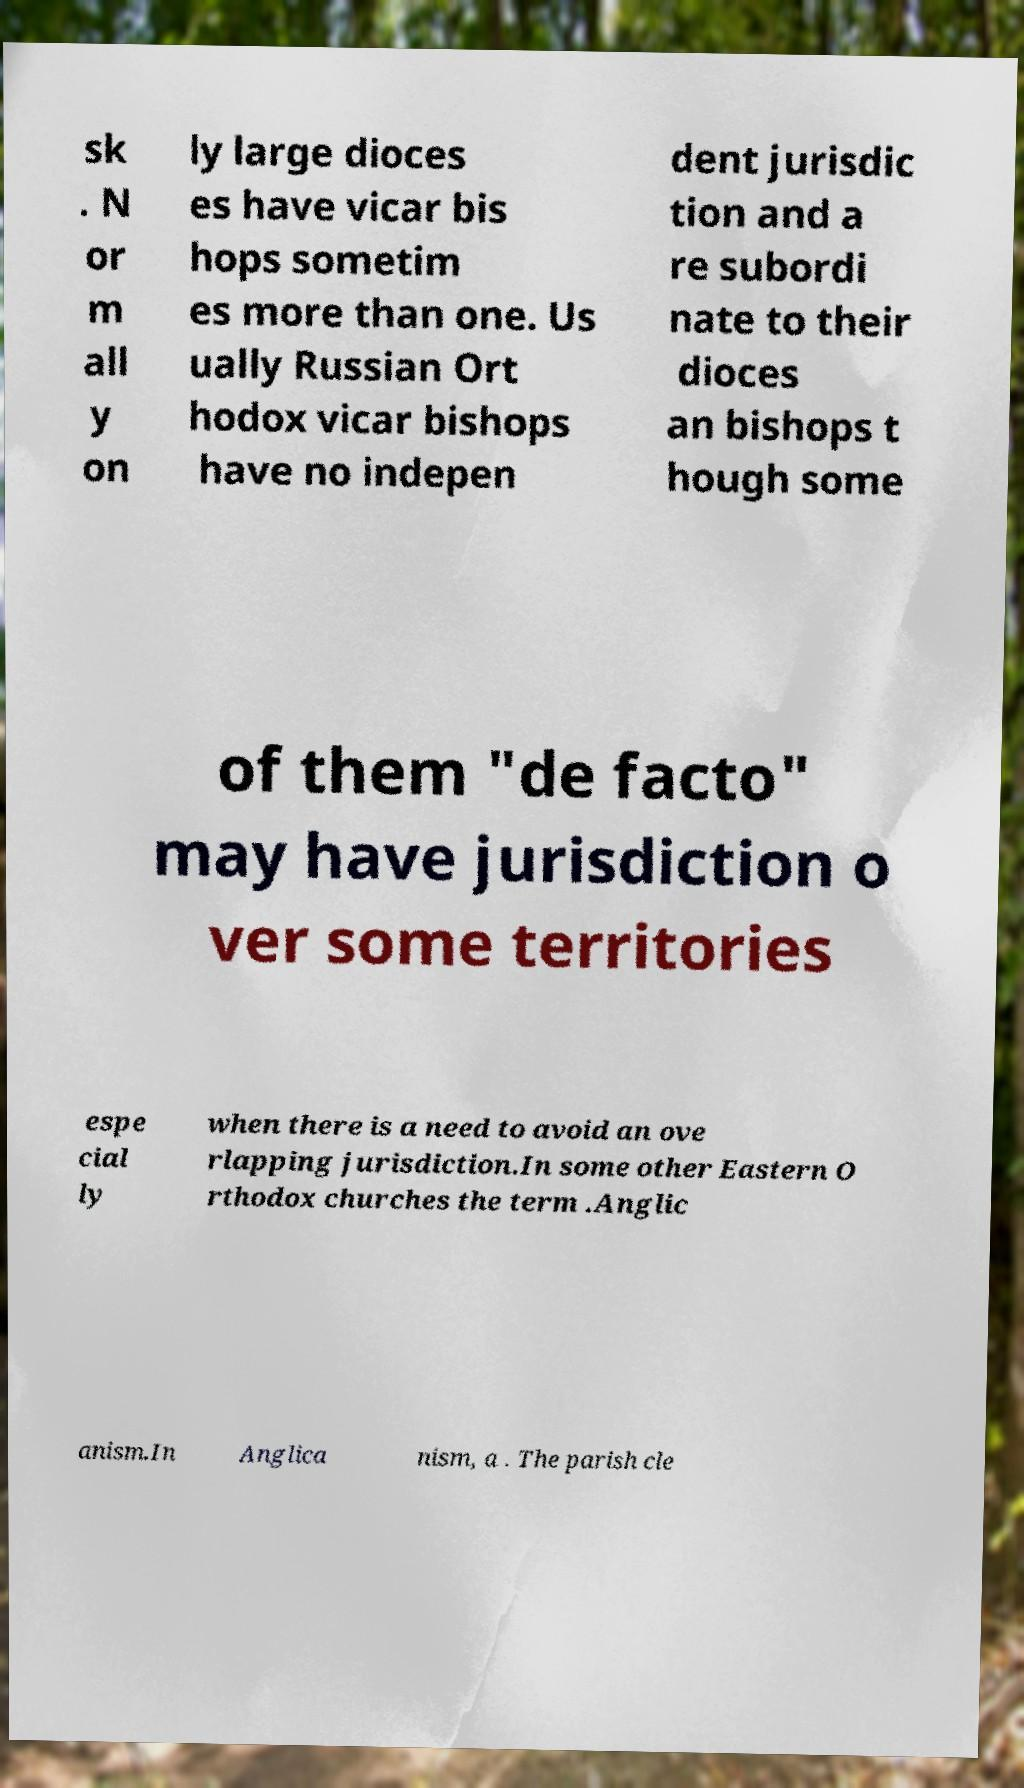Could you extract and type out the text from this image? sk . N or m all y on ly large dioces es have vicar bis hops sometim es more than one. Us ually Russian Ort hodox vicar bishops have no indepen dent jurisdic tion and a re subordi nate to their dioces an bishops t hough some of them "de facto" may have jurisdiction o ver some territories espe cial ly when there is a need to avoid an ove rlapping jurisdiction.In some other Eastern O rthodox churches the term .Anglic anism.In Anglica nism, a . The parish cle 